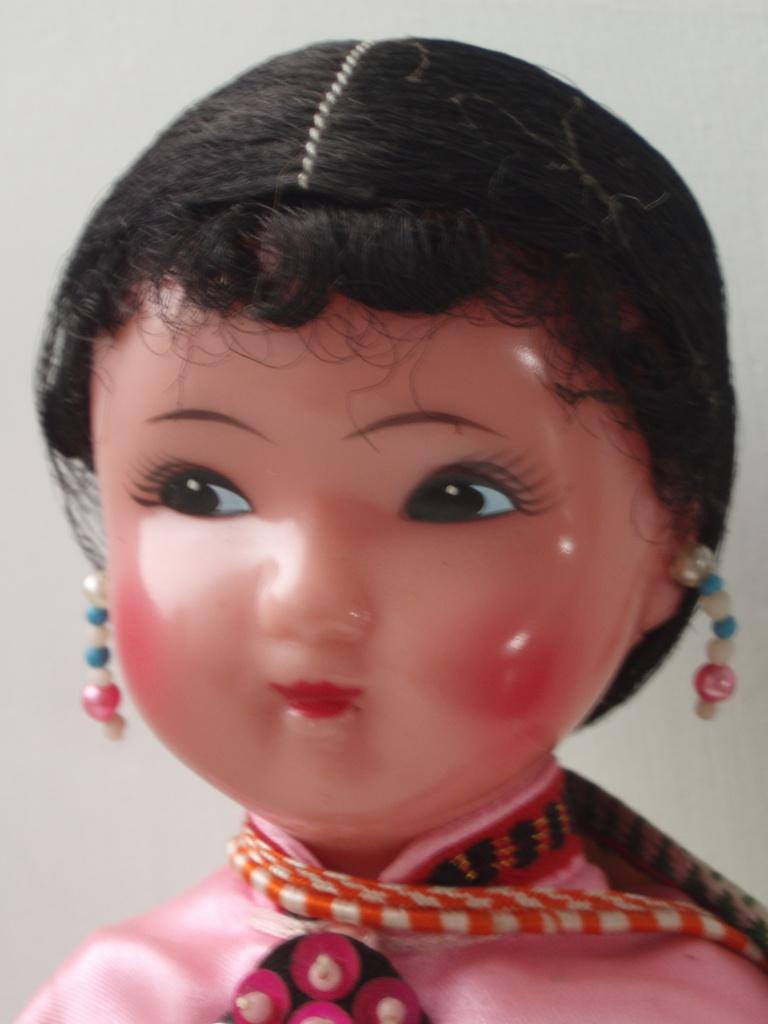Who is the main subject in the image? There is a girl depicted in the image. How many alleys can be seen behind the girl in the image? There is no alley present in the image; it only depicts a girl. What type of shelf is visible in the image? There is no shelf present in the image; it only depicts a girl. 